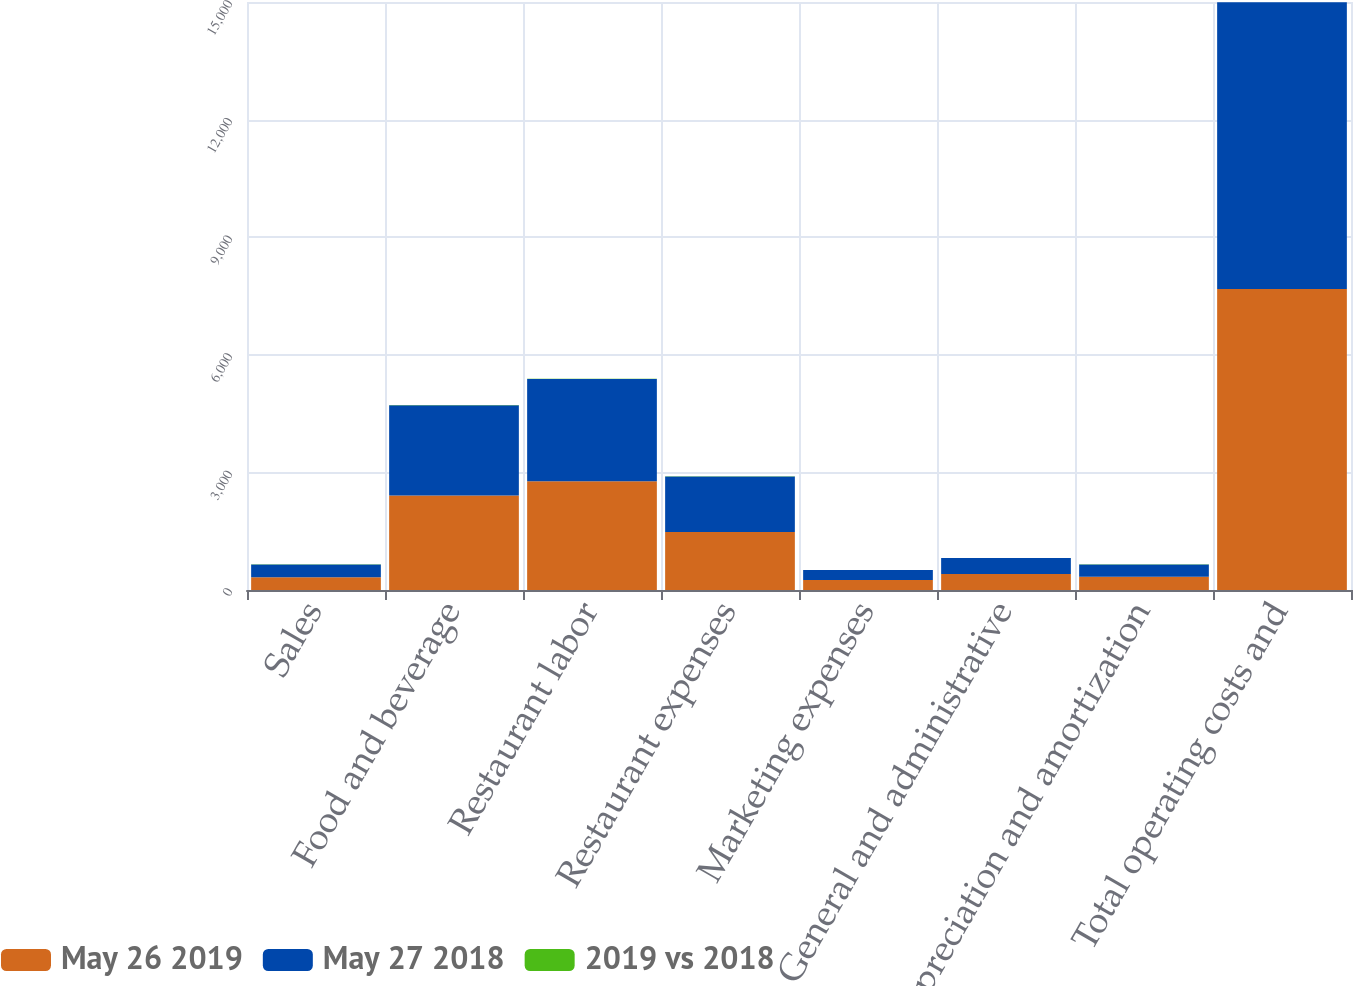<chart> <loc_0><loc_0><loc_500><loc_500><stacked_bar_chart><ecel><fcel>Sales<fcel>Food and beverage<fcel>Restaurant labor<fcel>Restaurant expenses<fcel>Marketing expenses<fcel>General and administrative<fcel>Depreciation and amortization<fcel>Total operating costs and<nl><fcel>May 26 2019<fcel>324.9<fcel>2412.5<fcel>2771.1<fcel>1477.8<fcel>255.3<fcel>405.5<fcel>336.7<fcel>7677.9<nl><fcel>May 27 2018<fcel>324.9<fcel>2303.1<fcel>2614.5<fcel>1417.1<fcel>252.3<fcel>409.8<fcel>313.1<fcel>7313.3<nl><fcel>2019 vs 2018<fcel>5.3<fcel>4.8<fcel>6<fcel>4.3<fcel>1.2<fcel>1<fcel>7.5<fcel>5<nl></chart> 